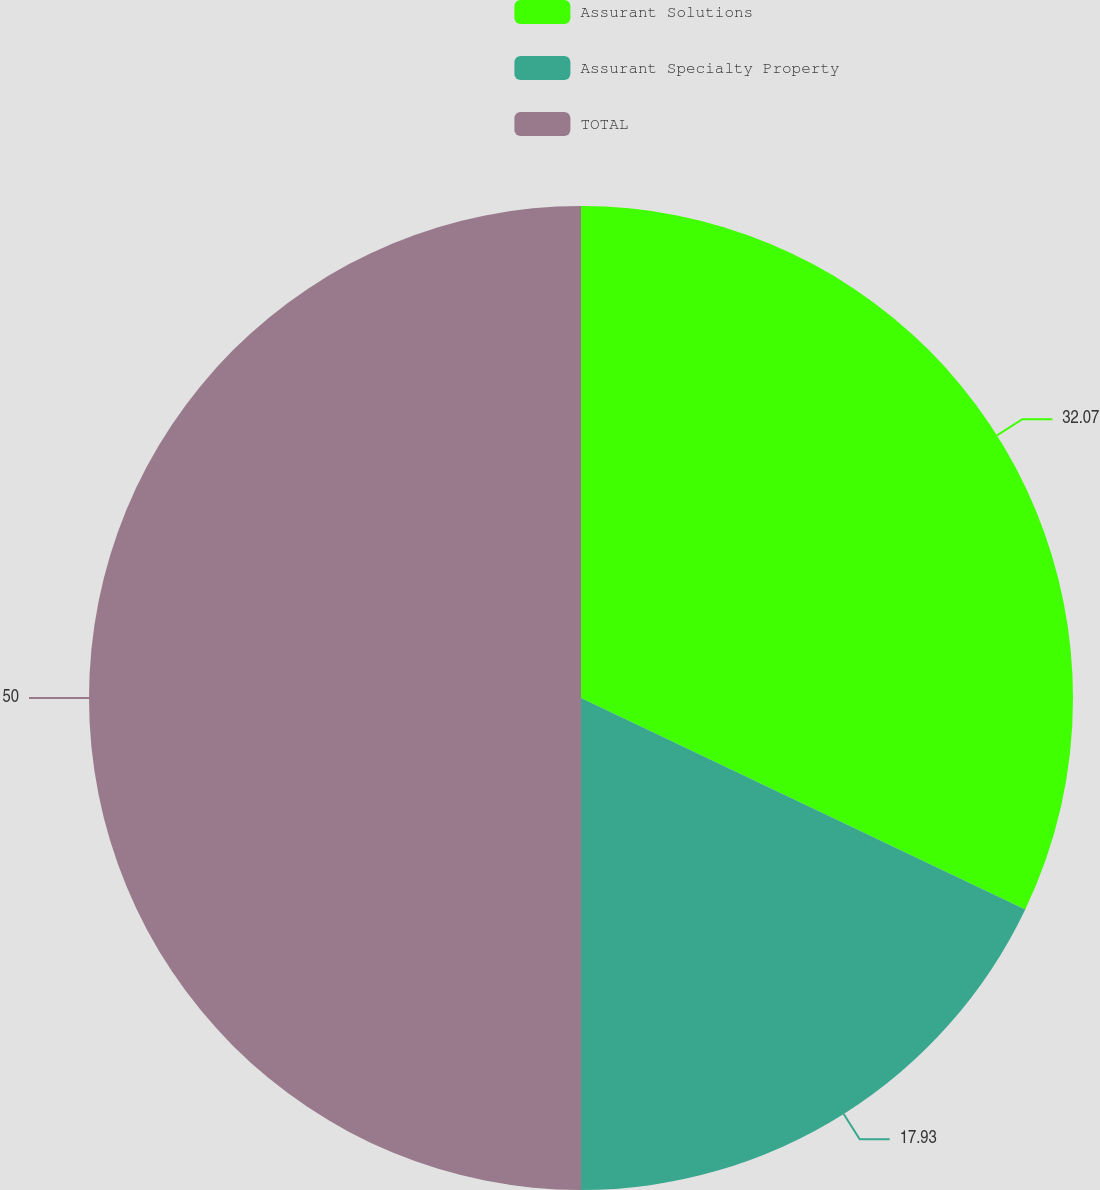<chart> <loc_0><loc_0><loc_500><loc_500><pie_chart><fcel>Assurant Solutions<fcel>Assurant Specialty Property<fcel>TOTAL<nl><fcel>32.07%<fcel>17.93%<fcel>50.0%<nl></chart> 